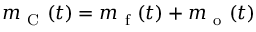Convert formula to latex. <formula><loc_0><loc_0><loc_500><loc_500>m _ { C } ( t ) = m _ { f } ( t ) + m _ { o } ( t )</formula> 